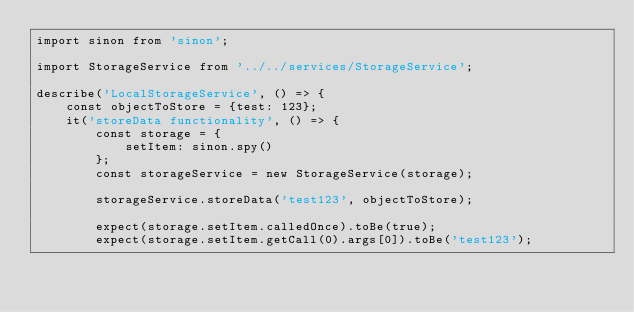<code> <loc_0><loc_0><loc_500><loc_500><_JavaScript_>import sinon from 'sinon';

import StorageService from '../../services/StorageService';

describe('LocalStorageService', () => {
    const objectToStore = {test: 123};
    it('storeData functionality', () => {
        const storage = { 
            setItem: sinon.spy()
        };
        const storageService = new StorageService(storage);

        storageService.storeData('test123', objectToStore);
        
        expect(storage.setItem.calledOnce).toBe(true);
        expect(storage.setItem.getCall(0).args[0]).toBe('test123');</code> 